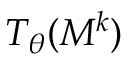Convert formula to latex. <formula><loc_0><loc_0><loc_500><loc_500>T _ { \theta } ( M ^ { k } )</formula> 